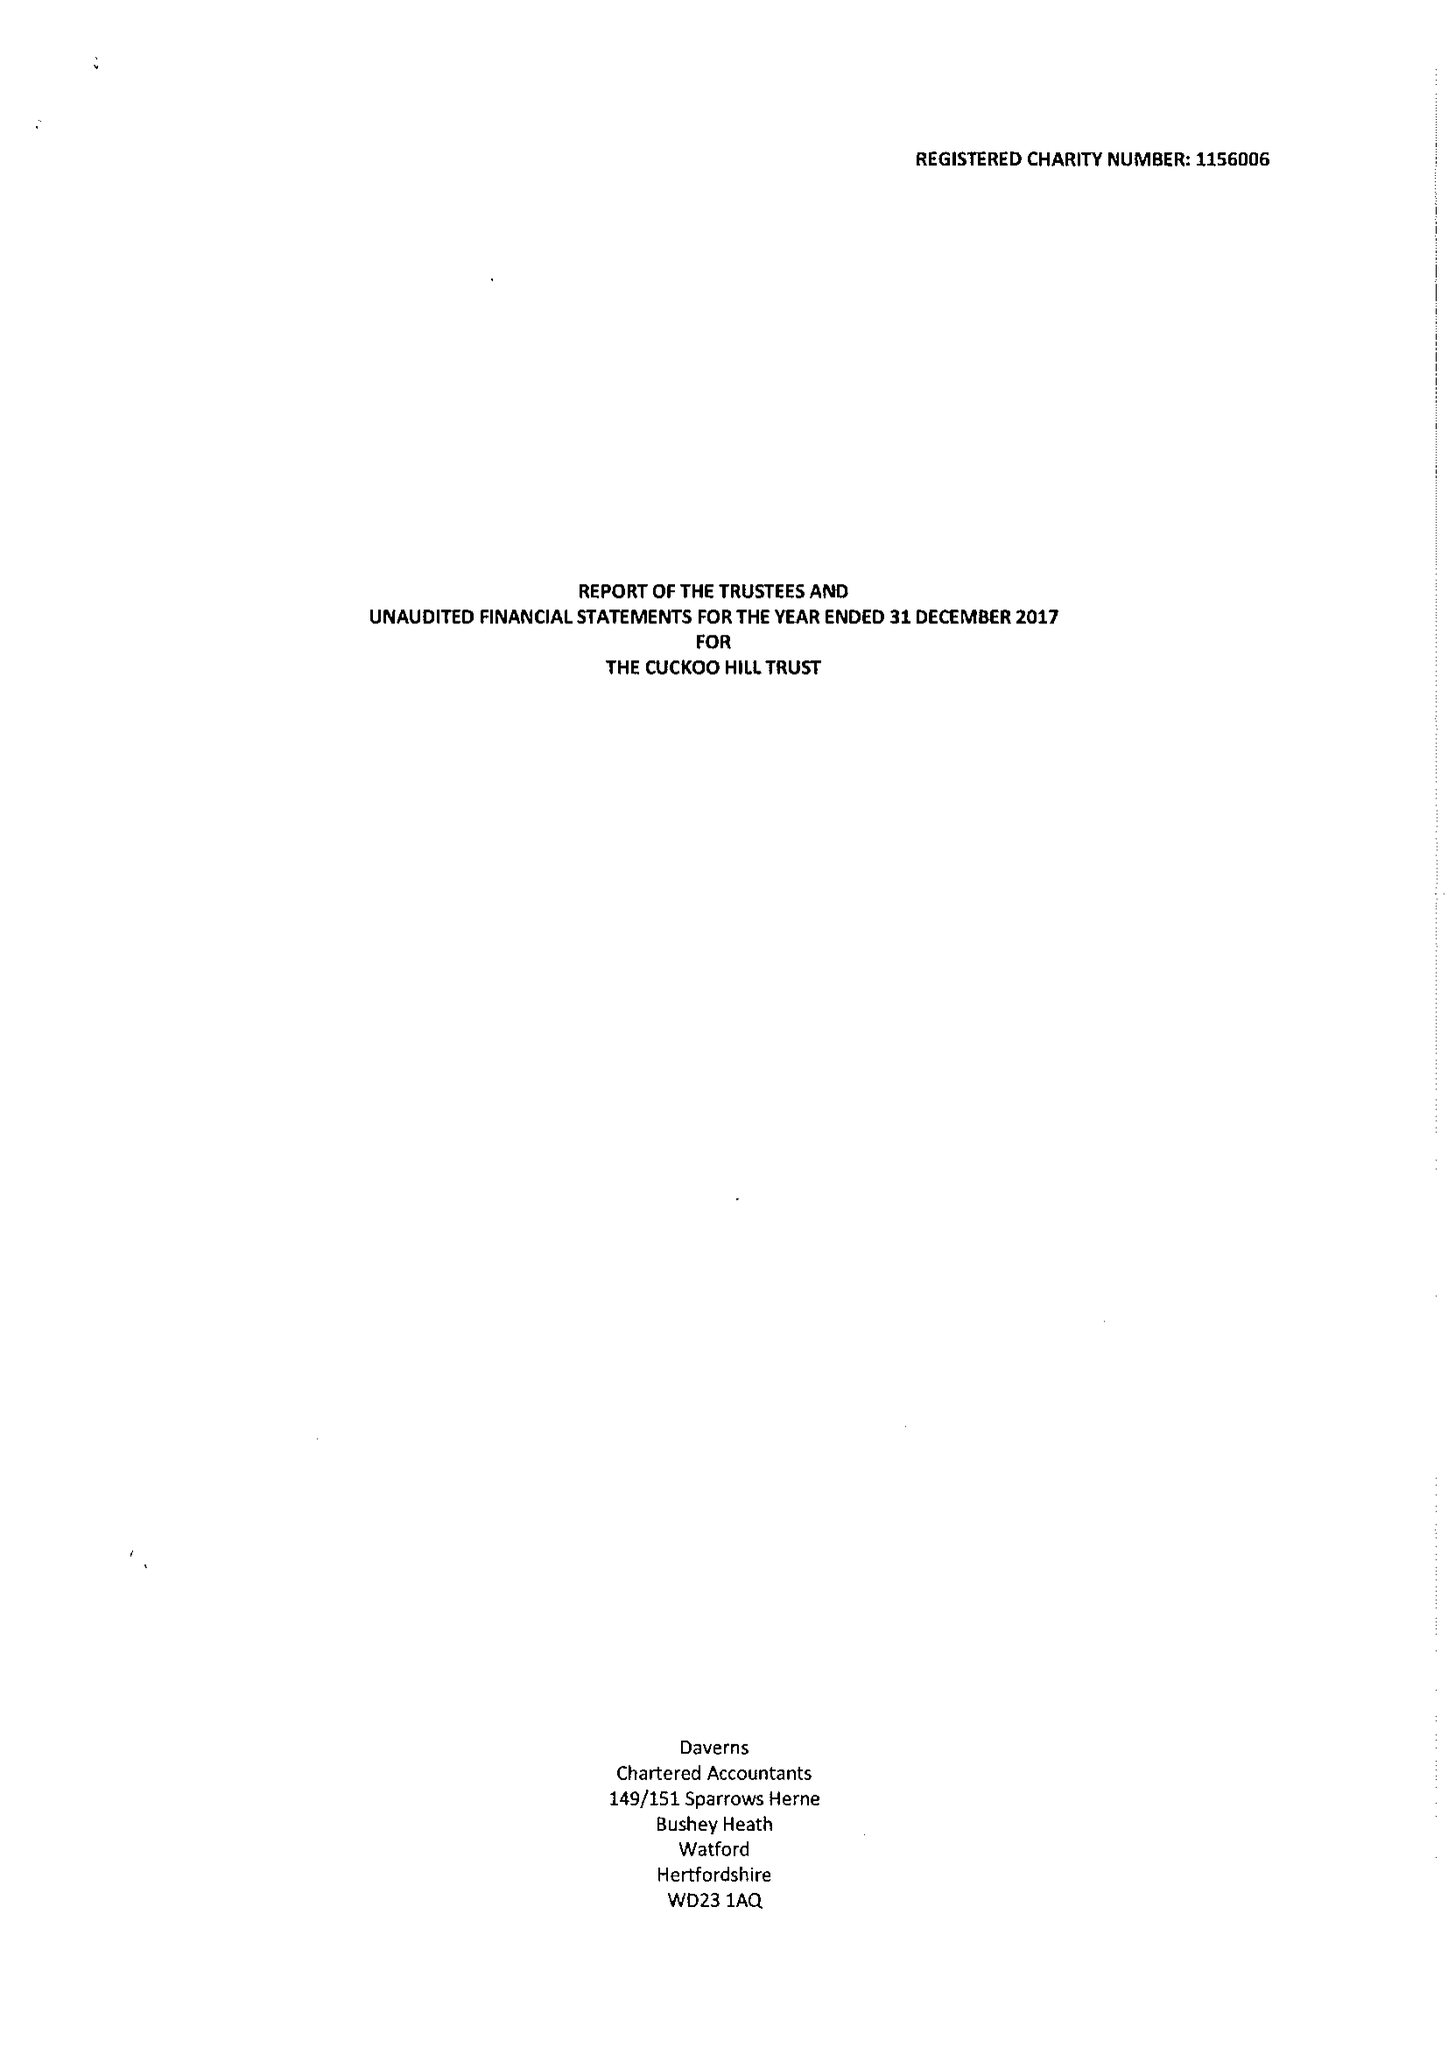What is the value for the charity_number?
Answer the question using a single word or phrase. 1156006 